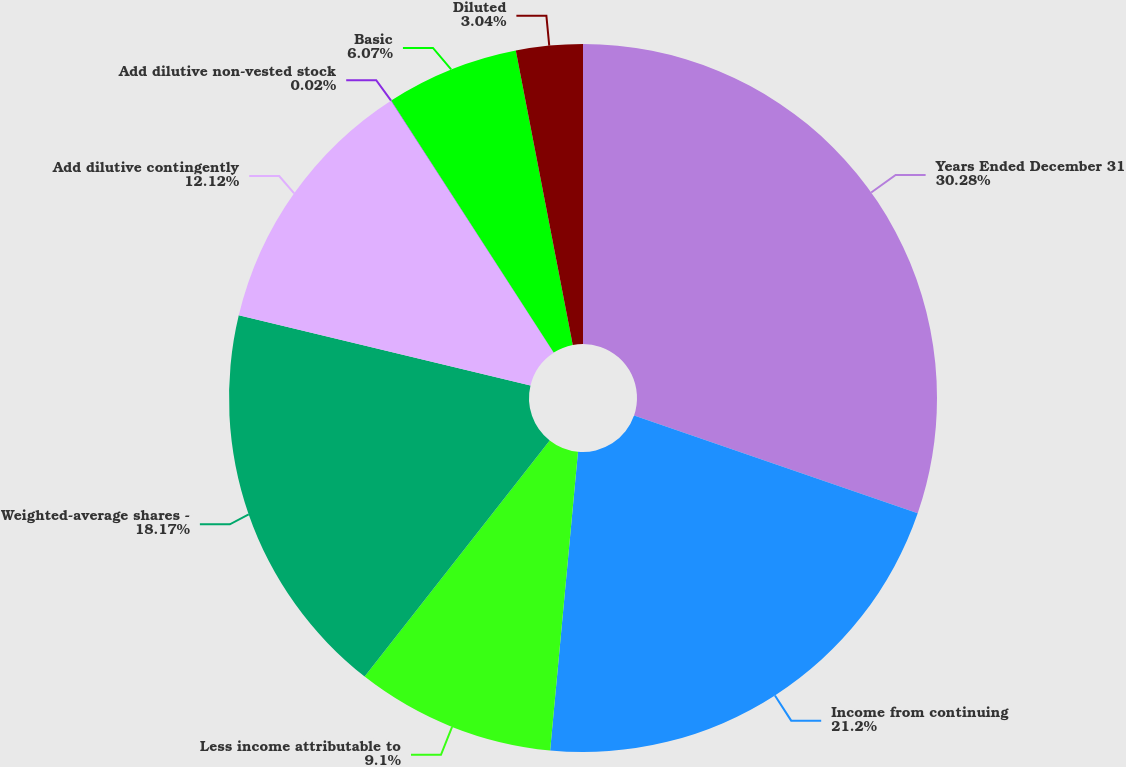<chart> <loc_0><loc_0><loc_500><loc_500><pie_chart><fcel>Years Ended December 31<fcel>Income from continuing<fcel>Less income attributable to<fcel>Weighted-average shares -<fcel>Add dilutive contingently<fcel>Add dilutive non-vested stock<fcel>Basic<fcel>Diluted<nl><fcel>30.28%<fcel>21.2%<fcel>9.1%<fcel>18.17%<fcel>12.12%<fcel>0.02%<fcel>6.07%<fcel>3.04%<nl></chart> 